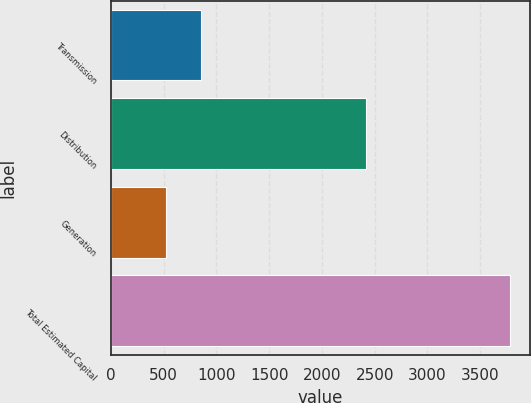Convert chart to OTSL. <chart><loc_0><loc_0><loc_500><loc_500><bar_chart><fcel>Transmission<fcel>Distribution<fcel>Generation<fcel>Total Estimated Capital<nl><fcel>850<fcel>2416<fcel>520<fcel>3786<nl></chart> 